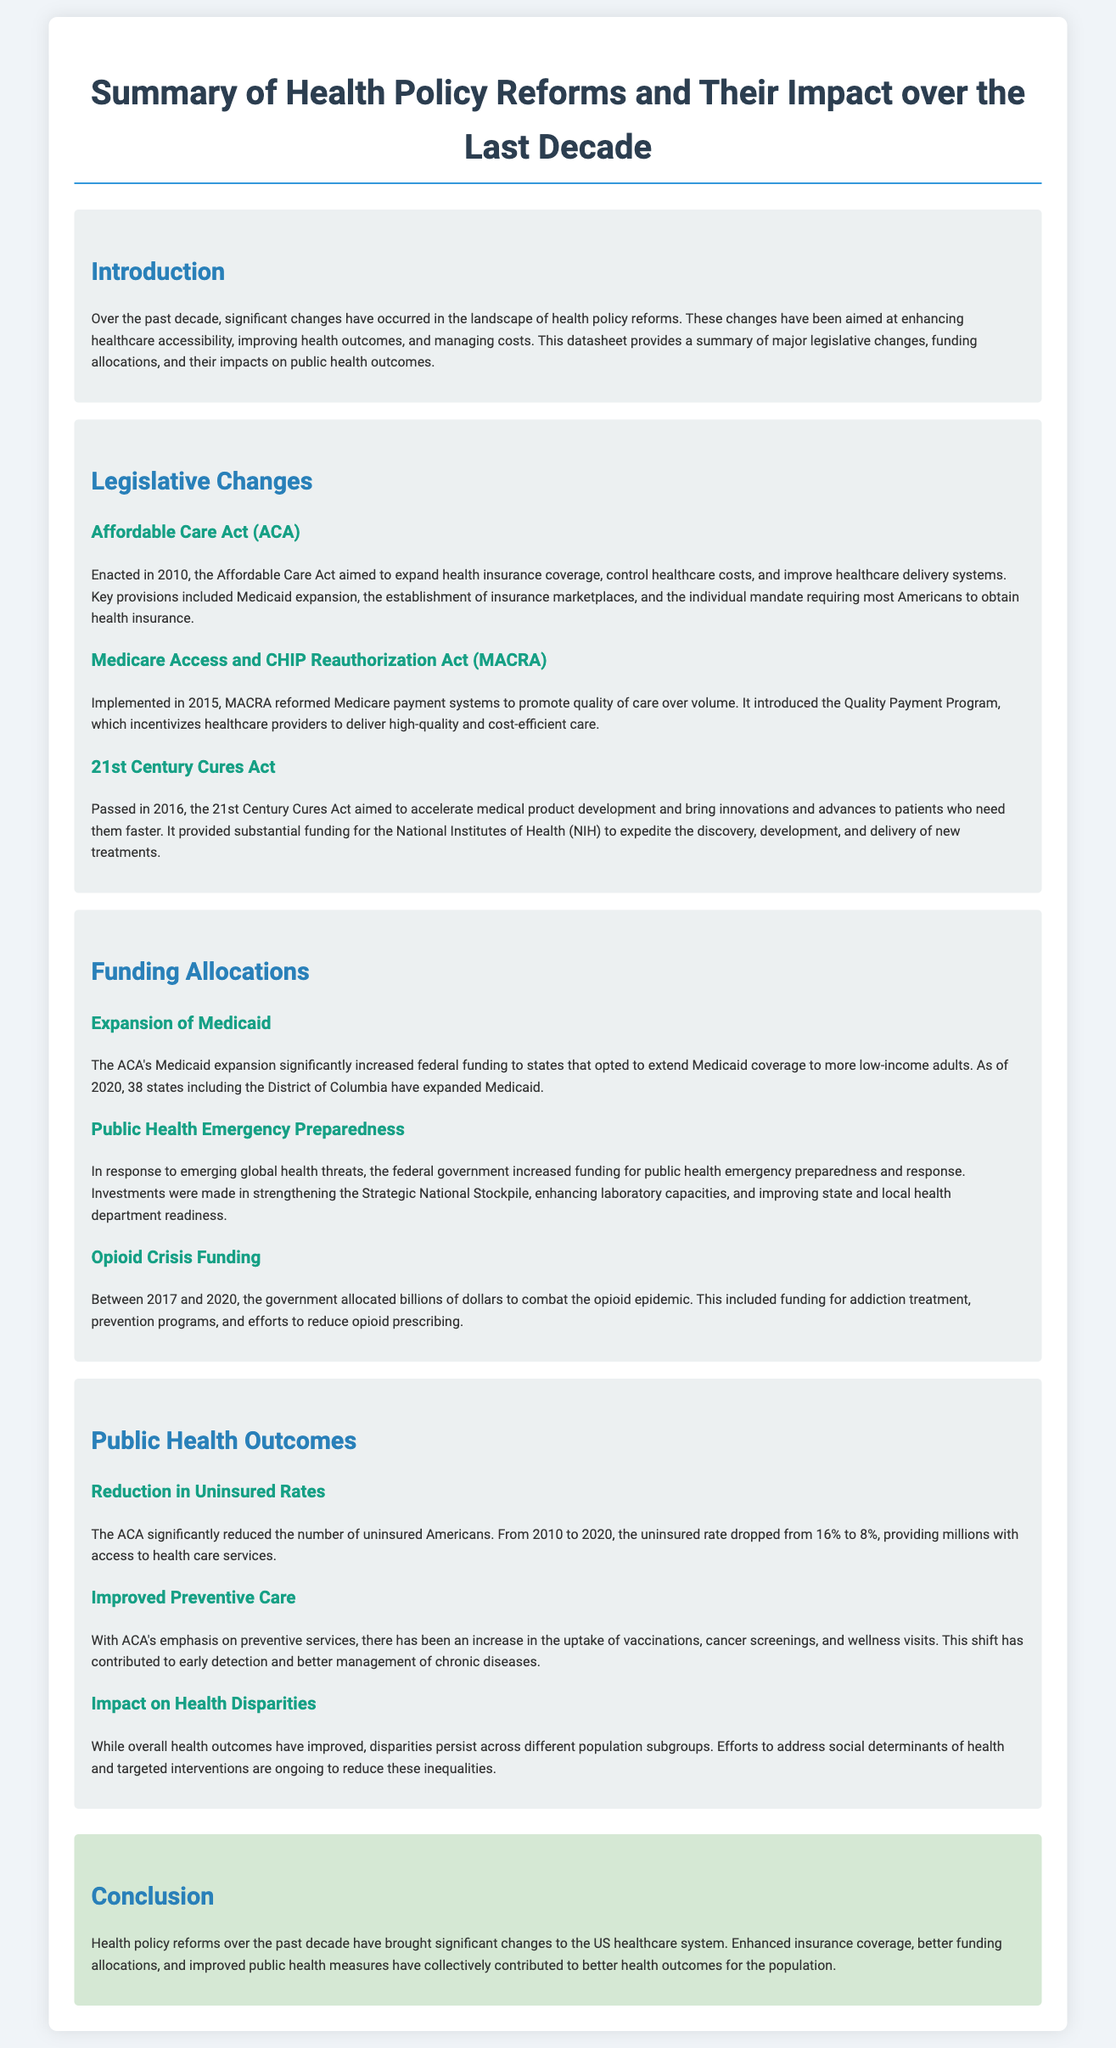what major health policy was enacted in 2010? The Affordable Care Act was enacted in 2010 to expand health insurance coverage.
Answer: Affordable Care Act what does MACRA stand for? MACRA stands for the Medicare Access and CHIP Reauthorization Act.
Answer: Medicare Access and CHIP Reauthorization Act how much did the uninsured rate drop from 2010 to 2020? The uninsured rate dropped from 16% to 8%, a decrease of 8 percentage points.
Answer: 8 percentage points which legislative act aimed to combat the opioid crisis? The document states the government allocated billions to combat the opioid epidemic, indicating a concerted effort.
Answer: Opioid crisis funding how many states expanded Medicaid as of 2020? The ACA's Medicaid expansion was implemented in 38 states including the District of Columbia.
Answer: 38 states what is one impact of the ACA on preventive care? The ACA has led to increases in vaccinations and cancer screenings, which are preventive services.
Answer: Increased vaccinations and screenings which act provided substantial funding for the NIH? The 21st Century Cures Act provided substantial funding for the National Institutes of Health.
Answer: 21st Century Cures Act what are ongoing efforts aiming to address in public health outcomes? Ongoing efforts aim to reduce health disparities across different population subgroups.
Answer: Health disparities what was a key focus of the Quality Payment Program introduced by MACRA? The Quality Payment Program focuses on incentivizing healthcare providers to deliver high-quality and cost-efficient care.
Answer: High-quality care 